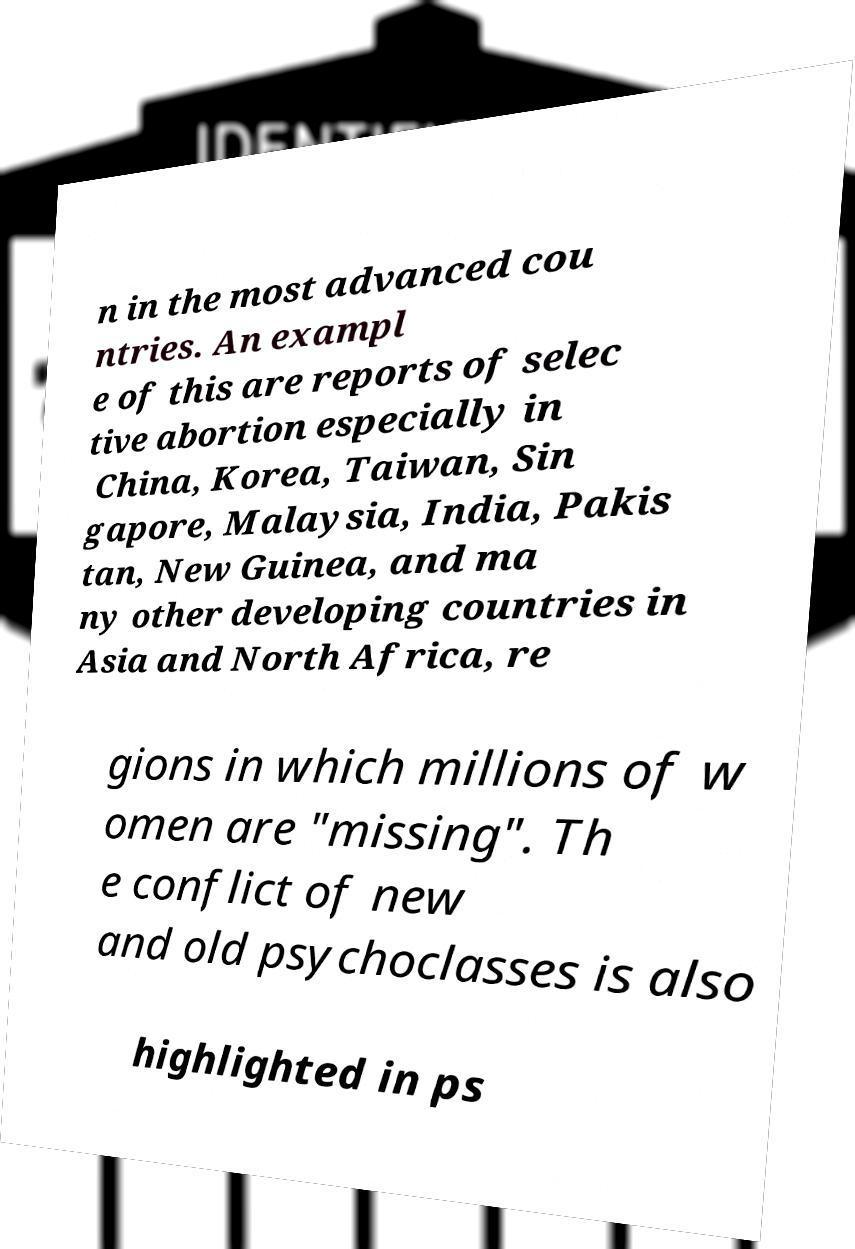Could you assist in decoding the text presented in this image and type it out clearly? n in the most advanced cou ntries. An exampl e of this are reports of selec tive abortion especially in China, Korea, Taiwan, Sin gapore, Malaysia, India, Pakis tan, New Guinea, and ma ny other developing countries in Asia and North Africa, re gions in which millions of w omen are "missing". Th e conflict of new and old psychoclasses is also highlighted in ps 